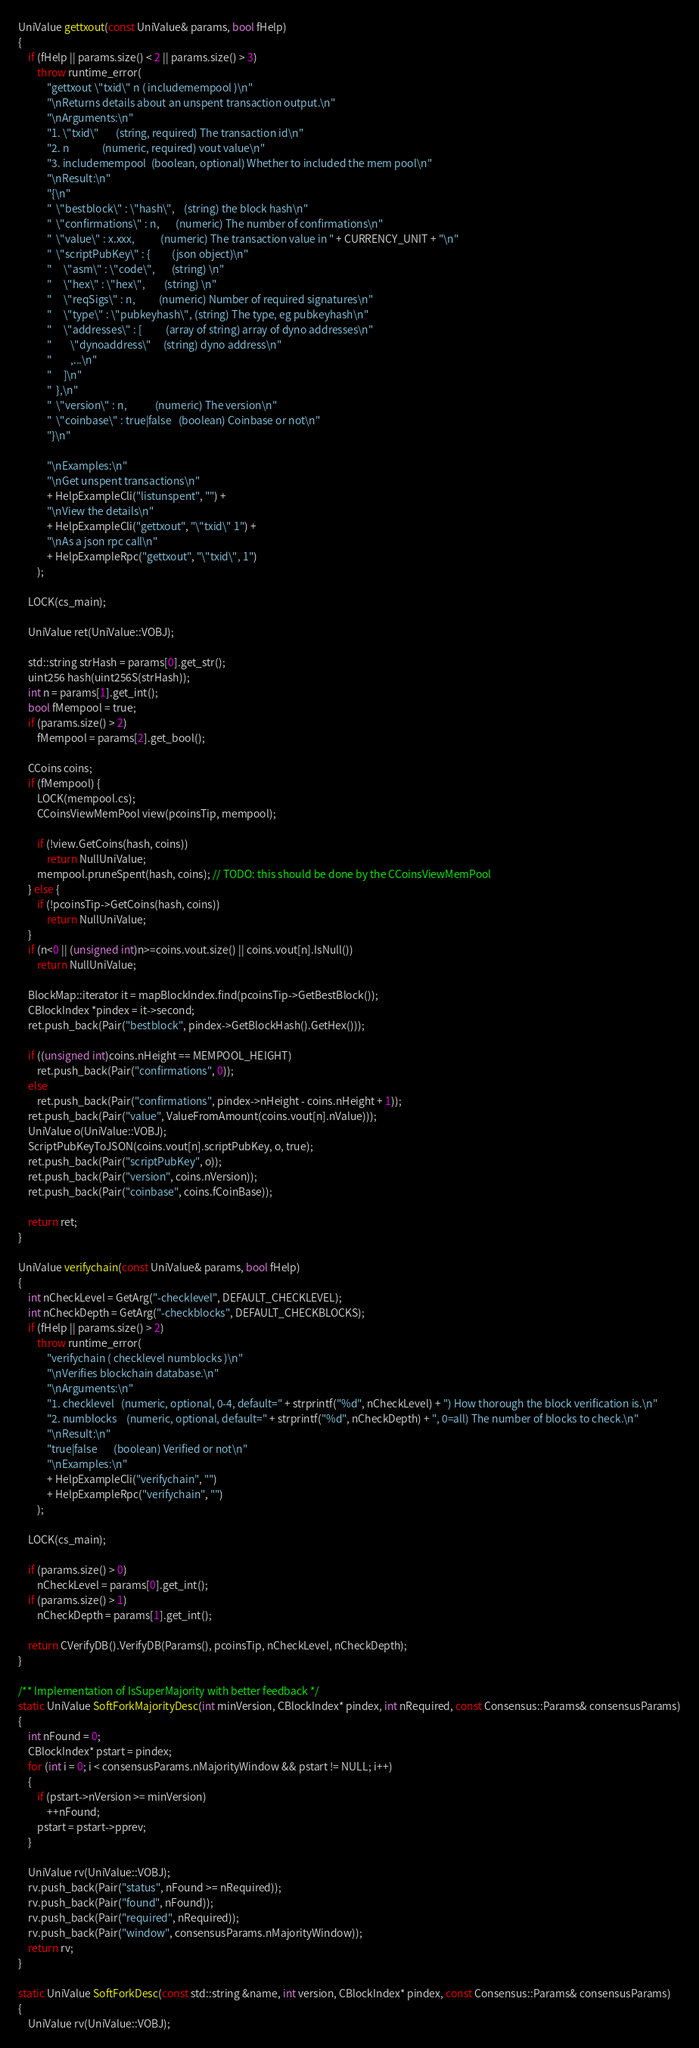<code> <loc_0><loc_0><loc_500><loc_500><_C++_>UniValue gettxout(const UniValue& params, bool fHelp)
{
    if (fHelp || params.size() < 2 || params.size() > 3)
        throw runtime_error(
            "gettxout \"txid\" n ( includemempool )\n"
            "\nReturns details about an unspent transaction output.\n"
            "\nArguments:\n"
            "1. \"txid\"       (string, required) The transaction id\n"
            "2. n              (numeric, required) vout value\n"
            "3. includemempool  (boolean, optional) Whether to included the mem pool\n"
            "\nResult:\n"
            "{\n"
            "  \"bestblock\" : \"hash\",    (string) the block hash\n"
            "  \"confirmations\" : n,       (numeric) The number of confirmations\n"
            "  \"value\" : x.xxx,           (numeric) The transaction value in " + CURRENCY_UNIT + "\n"
            "  \"scriptPubKey\" : {         (json object)\n"
            "     \"asm\" : \"code\",       (string) \n"
            "     \"hex\" : \"hex\",        (string) \n"
            "     \"reqSigs\" : n,          (numeric) Number of required signatures\n"
            "     \"type\" : \"pubkeyhash\", (string) The type, eg pubkeyhash\n"
            "     \"addresses\" : [          (array of string) array of dyno addresses\n"
            "        \"dynoaddress\"     (string) dyno address\n"
            "        ,...\n"
            "     ]\n"
            "  },\n"
            "  \"version\" : n,            (numeric) The version\n"
            "  \"coinbase\" : true|false   (boolean) Coinbase or not\n"
            "}\n"

            "\nExamples:\n"
            "\nGet unspent transactions\n"
            + HelpExampleCli("listunspent", "") +
            "\nView the details\n"
            + HelpExampleCli("gettxout", "\"txid\" 1") +
            "\nAs a json rpc call\n"
            + HelpExampleRpc("gettxout", "\"txid\", 1")
        );

    LOCK(cs_main);

    UniValue ret(UniValue::VOBJ);

    std::string strHash = params[0].get_str();
    uint256 hash(uint256S(strHash));
    int n = params[1].get_int();
    bool fMempool = true;
    if (params.size() > 2)
        fMempool = params[2].get_bool();

    CCoins coins;
    if (fMempool) {
        LOCK(mempool.cs);
        CCoinsViewMemPool view(pcoinsTip, mempool);

        if (!view.GetCoins(hash, coins))
            return NullUniValue;
        mempool.pruneSpent(hash, coins); // TODO: this should be done by the CCoinsViewMemPool
    } else {
        if (!pcoinsTip->GetCoins(hash, coins))
            return NullUniValue;
    }
    if (n<0 || (unsigned int)n>=coins.vout.size() || coins.vout[n].IsNull())
        return NullUniValue;

    BlockMap::iterator it = mapBlockIndex.find(pcoinsTip->GetBestBlock());
    CBlockIndex *pindex = it->second;
    ret.push_back(Pair("bestblock", pindex->GetBlockHash().GetHex()));

    if ((unsigned int)coins.nHeight == MEMPOOL_HEIGHT)
        ret.push_back(Pair("confirmations", 0));
    else
        ret.push_back(Pair("confirmations", pindex->nHeight - coins.nHeight + 1));
    ret.push_back(Pair("value", ValueFromAmount(coins.vout[n].nValue)));
    UniValue o(UniValue::VOBJ);
    ScriptPubKeyToJSON(coins.vout[n].scriptPubKey, o, true);
    ret.push_back(Pair("scriptPubKey", o));
    ret.push_back(Pair("version", coins.nVersion));
    ret.push_back(Pair("coinbase", coins.fCoinBase));

    return ret;
}

UniValue verifychain(const UniValue& params, bool fHelp)
{
    int nCheckLevel = GetArg("-checklevel", DEFAULT_CHECKLEVEL);
    int nCheckDepth = GetArg("-checkblocks", DEFAULT_CHECKBLOCKS);
    if (fHelp || params.size() > 2)
        throw runtime_error(
            "verifychain ( checklevel numblocks )\n"
            "\nVerifies blockchain database.\n"
            "\nArguments:\n"
            "1. checklevel   (numeric, optional, 0-4, default=" + strprintf("%d", nCheckLevel) + ") How thorough the block verification is.\n"
            "2. numblocks    (numeric, optional, default=" + strprintf("%d", nCheckDepth) + ", 0=all) The number of blocks to check.\n"
            "\nResult:\n"
            "true|false       (boolean) Verified or not\n"
            "\nExamples:\n"
            + HelpExampleCli("verifychain", "")
            + HelpExampleRpc("verifychain", "")
        );

    LOCK(cs_main);

    if (params.size() > 0)
        nCheckLevel = params[0].get_int();
    if (params.size() > 1)
        nCheckDepth = params[1].get_int();

    return CVerifyDB().VerifyDB(Params(), pcoinsTip, nCheckLevel, nCheckDepth);
}

/** Implementation of IsSuperMajority with better feedback */
static UniValue SoftForkMajorityDesc(int minVersion, CBlockIndex* pindex, int nRequired, const Consensus::Params& consensusParams)
{
    int nFound = 0;
    CBlockIndex* pstart = pindex;
    for (int i = 0; i < consensusParams.nMajorityWindow && pstart != NULL; i++)
    {
        if (pstart->nVersion >= minVersion)
            ++nFound;
        pstart = pstart->pprev;
    }

    UniValue rv(UniValue::VOBJ);
    rv.push_back(Pair("status", nFound >= nRequired));
    rv.push_back(Pair("found", nFound));
    rv.push_back(Pair("required", nRequired));
    rv.push_back(Pair("window", consensusParams.nMajorityWindow));
    return rv;
}

static UniValue SoftForkDesc(const std::string &name, int version, CBlockIndex* pindex, const Consensus::Params& consensusParams)
{
    UniValue rv(UniValue::VOBJ);</code> 